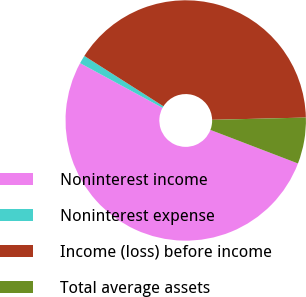Convert chart to OTSL. <chart><loc_0><loc_0><loc_500><loc_500><pie_chart><fcel>Noninterest income<fcel>Noninterest expense<fcel>Income (loss) before income<fcel>Total average assets<nl><fcel>52.09%<fcel>1.11%<fcel>40.59%<fcel>6.21%<nl></chart> 